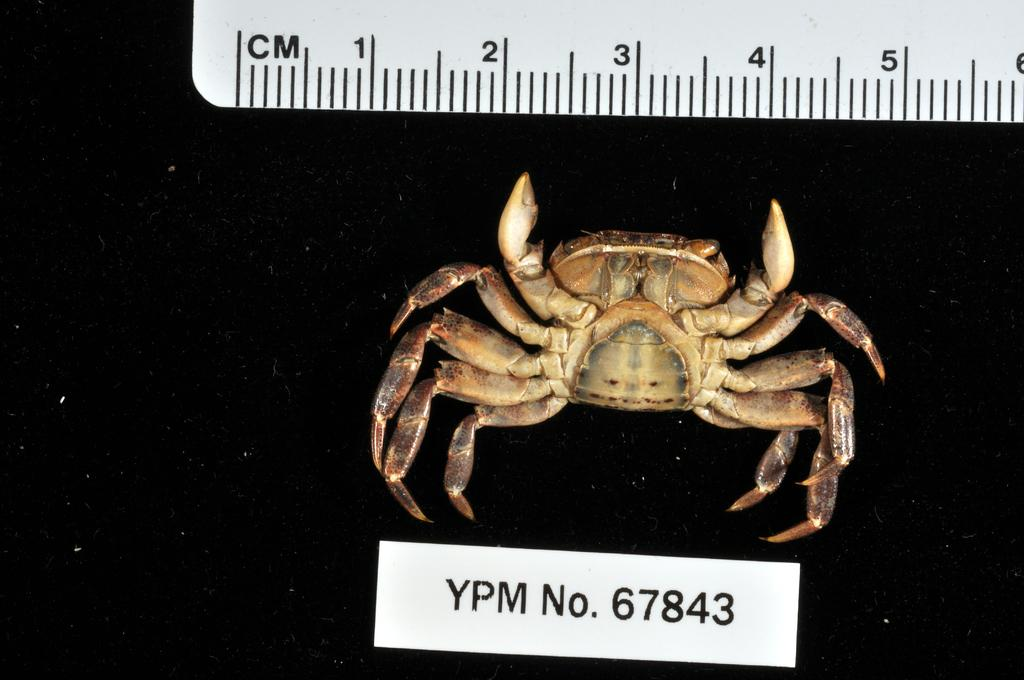What is the main subject in the center of the image? There is a crab in the center of the image. What object can be seen in the image that is used for measuring weight? There is a scale in the image. How would you describe the overall lighting in the image? The background of the image is dark. Where is the text located in the image? The text is located at the bottom of the image. What type of flame can be seen burning near the crab in the image? There is no flame present in the image; it features a crab and a scale with a dark background. 